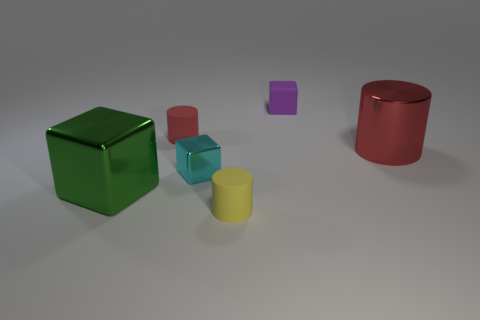What is the color of the tiny cube in front of the red cylinder in front of the tiny rubber thing to the left of the yellow object?
Provide a short and direct response. Cyan. Is the material of the small yellow cylinder the same as the small cyan cube?
Give a very brief answer. No. What number of green objects are either tiny rubber cylinders or metal cubes?
Make the answer very short. 1. There is a tiny rubber cube; how many objects are in front of it?
Give a very brief answer. 5. Are there more tiny things than objects?
Offer a terse response. No. What shape is the rubber object behind the red cylinder behind the big red metal cylinder?
Provide a succinct answer. Cube. Is the number of matte objects in front of the big metallic cylinder greater than the number of big metal cylinders?
Your answer should be very brief. No. How many tiny cyan metal things are behind the big green metal thing on the left side of the big red thing?
Give a very brief answer. 1. Do the large object in front of the tiny shiny object and the thing to the right of the tiny purple thing have the same material?
Give a very brief answer. Yes. There is a object that is the same color as the metal cylinder; what is it made of?
Give a very brief answer. Rubber. 